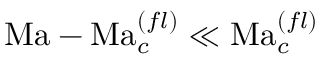<formula> <loc_0><loc_0><loc_500><loc_500>M a - M a _ { c } ^ { ( f l ) } \ll M a _ { c } ^ { ( f l ) }</formula> 